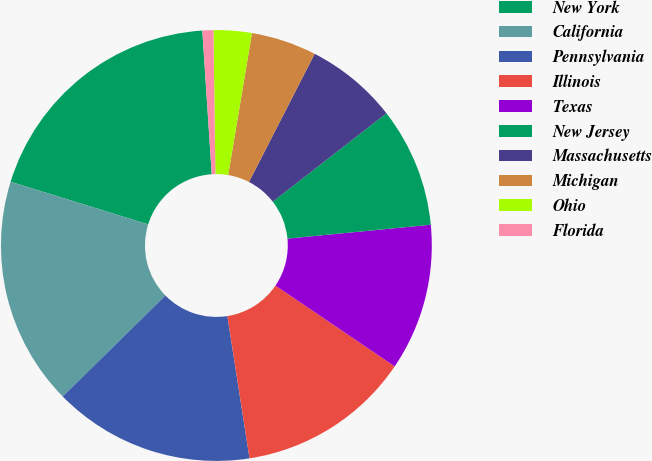Convert chart. <chart><loc_0><loc_0><loc_500><loc_500><pie_chart><fcel>New York<fcel>California<fcel>Pennsylvania<fcel>Illinois<fcel>Texas<fcel>New Jersey<fcel>Massachusetts<fcel>Michigan<fcel>Ohio<fcel>Florida<nl><fcel>19.18%<fcel>17.14%<fcel>15.1%<fcel>13.06%<fcel>11.02%<fcel>8.98%<fcel>6.94%<fcel>4.9%<fcel>2.86%<fcel>0.82%<nl></chart> 